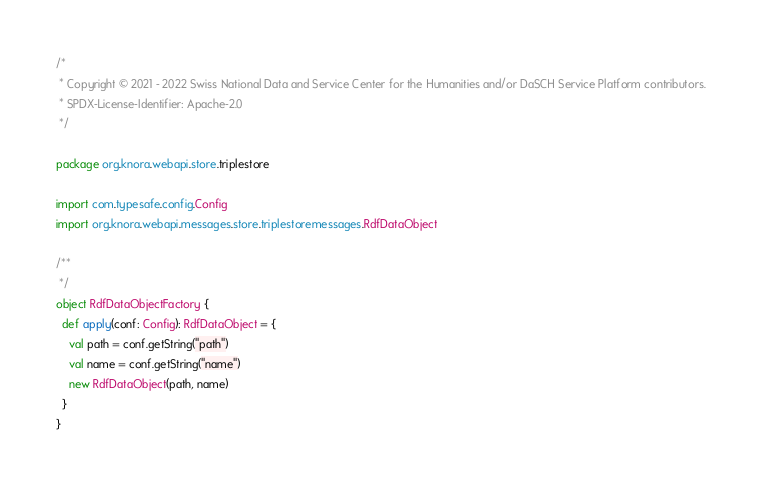<code> <loc_0><loc_0><loc_500><loc_500><_Scala_>/*
 * Copyright © 2021 - 2022 Swiss National Data and Service Center for the Humanities and/or DaSCH Service Platform contributors.
 * SPDX-License-Identifier: Apache-2.0
 */

package org.knora.webapi.store.triplestore

import com.typesafe.config.Config
import org.knora.webapi.messages.store.triplestoremessages.RdfDataObject

/**
 */
object RdfDataObjectFactory {
  def apply(conf: Config): RdfDataObject = {
    val path = conf.getString("path")
    val name = conf.getString("name")
    new RdfDataObject(path, name)
  }
}
</code> 